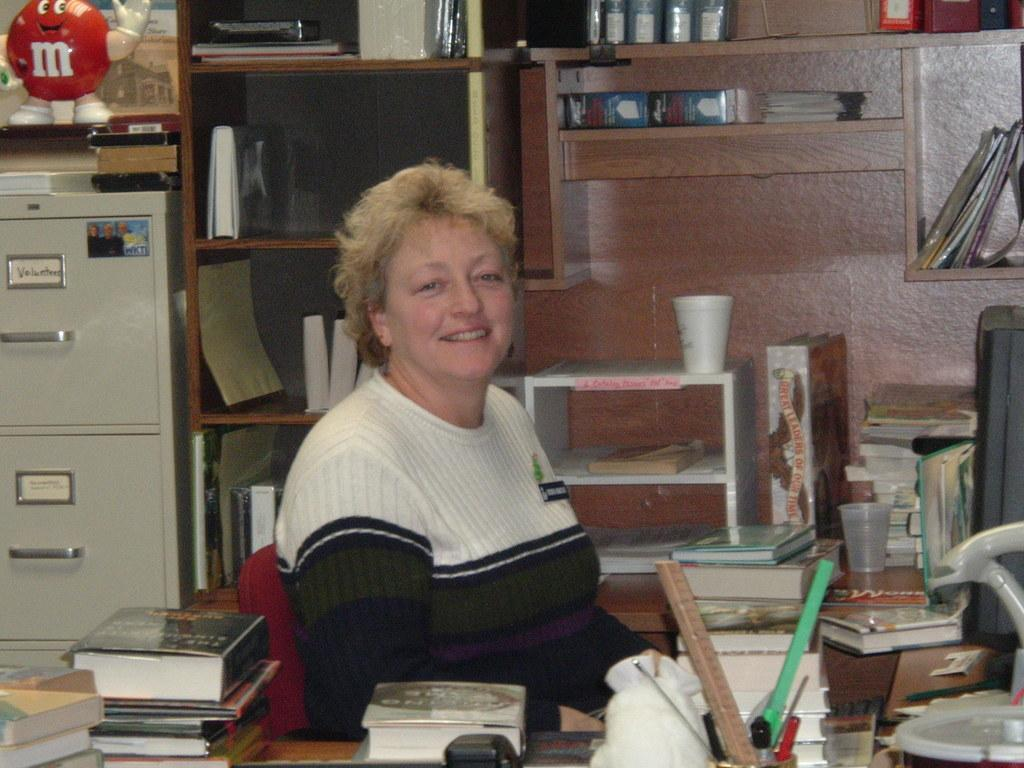What is the woman in the image doing? The woman is sitting in a chair. What is located in front of the woman? There is a table in front of the woman. What items can be seen on the table? There are books on the table. How many sisters does the woman have in the image? There is no information about the woman's sisters in the image. What type of tramp is visible in the image? There is no tramp present in the image. 